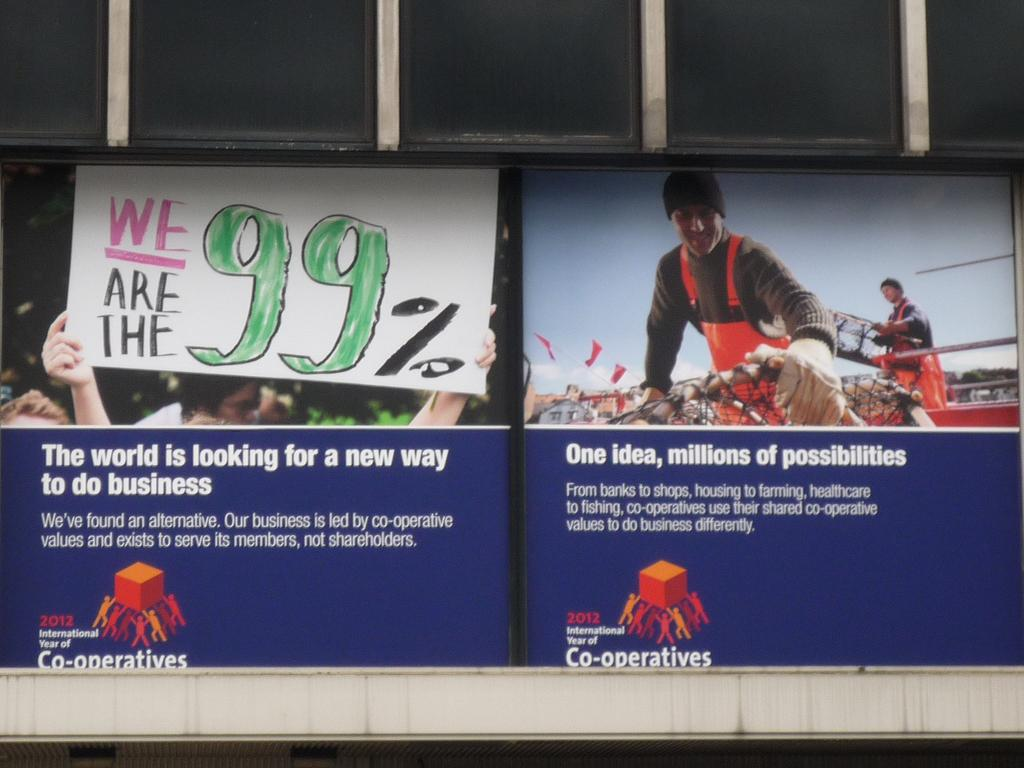What is on the building in the image? There is a banner on a building in the image. Can you describe the banner? The banner has at least two persons present on it. What else can be seen in the image besides the banner? There is a play card present in the image. How many bikes are parked near the gate in the image? There are no bikes or gates present in the image; it only features a banner with persons and a play card. 